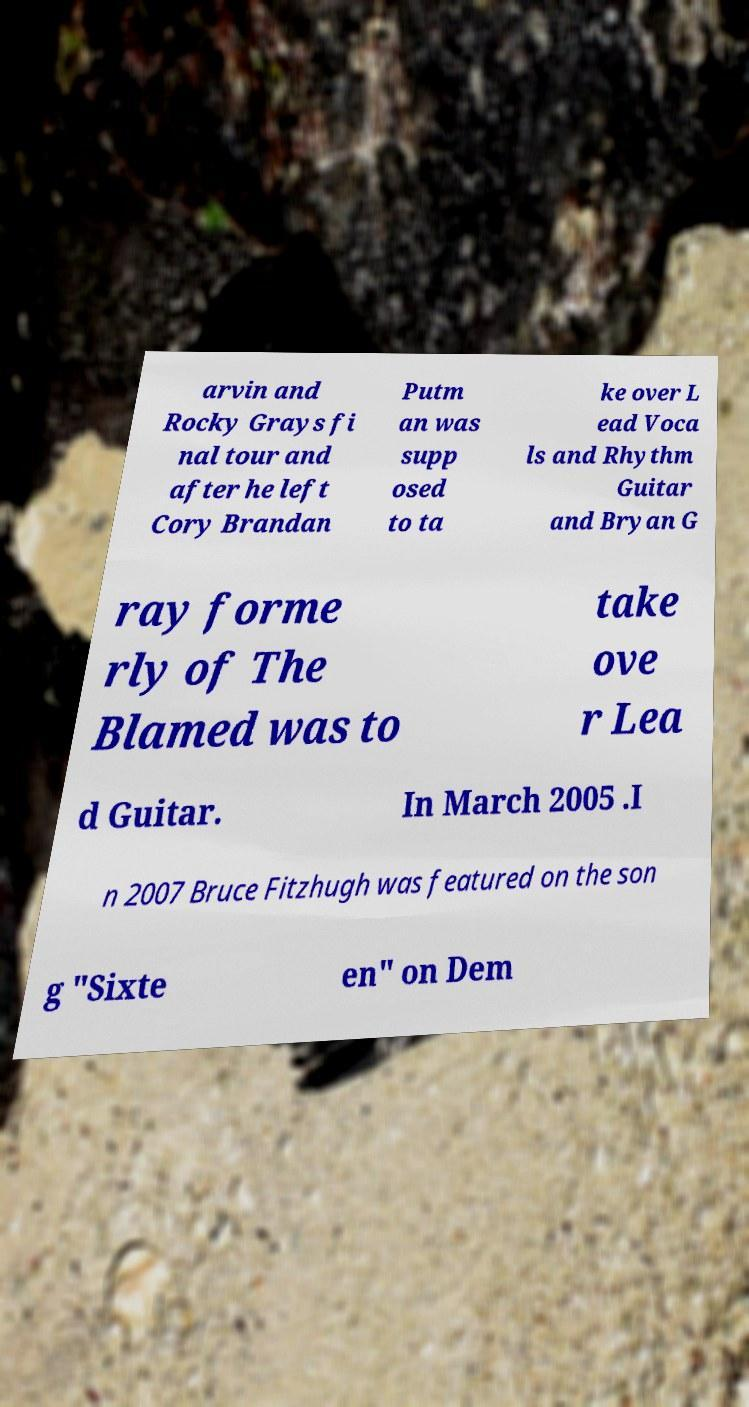Can you read and provide the text displayed in the image?This photo seems to have some interesting text. Can you extract and type it out for me? arvin and Rocky Grays fi nal tour and after he left Cory Brandan Putm an was supp osed to ta ke over L ead Voca ls and Rhythm Guitar and Bryan G ray forme rly of The Blamed was to take ove r Lea d Guitar. In March 2005 .I n 2007 Bruce Fitzhugh was featured on the son g "Sixte en" on Dem 